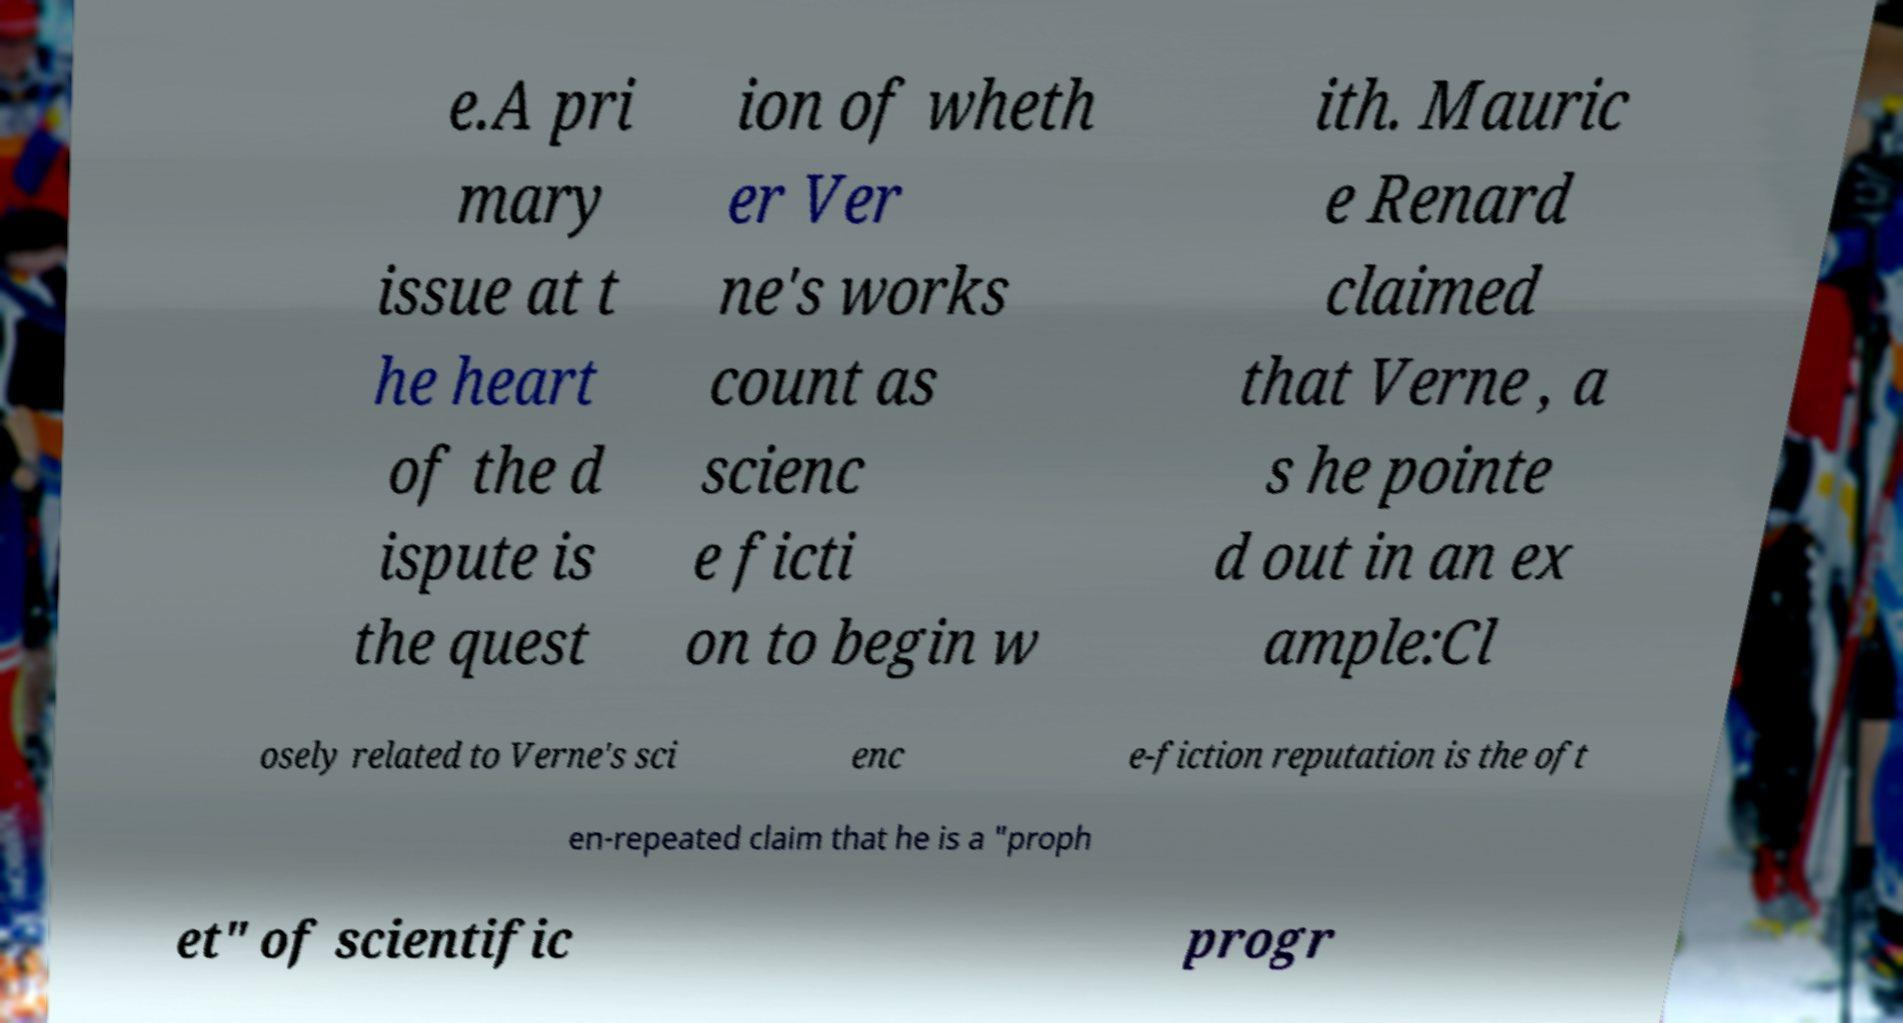Can you read and provide the text displayed in the image?This photo seems to have some interesting text. Can you extract and type it out for me? e.A pri mary issue at t he heart of the d ispute is the quest ion of wheth er Ver ne's works count as scienc e ficti on to begin w ith. Mauric e Renard claimed that Verne , a s he pointe d out in an ex ample:Cl osely related to Verne's sci enc e-fiction reputation is the oft en-repeated claim that he is a "proph et" of scientific progr 